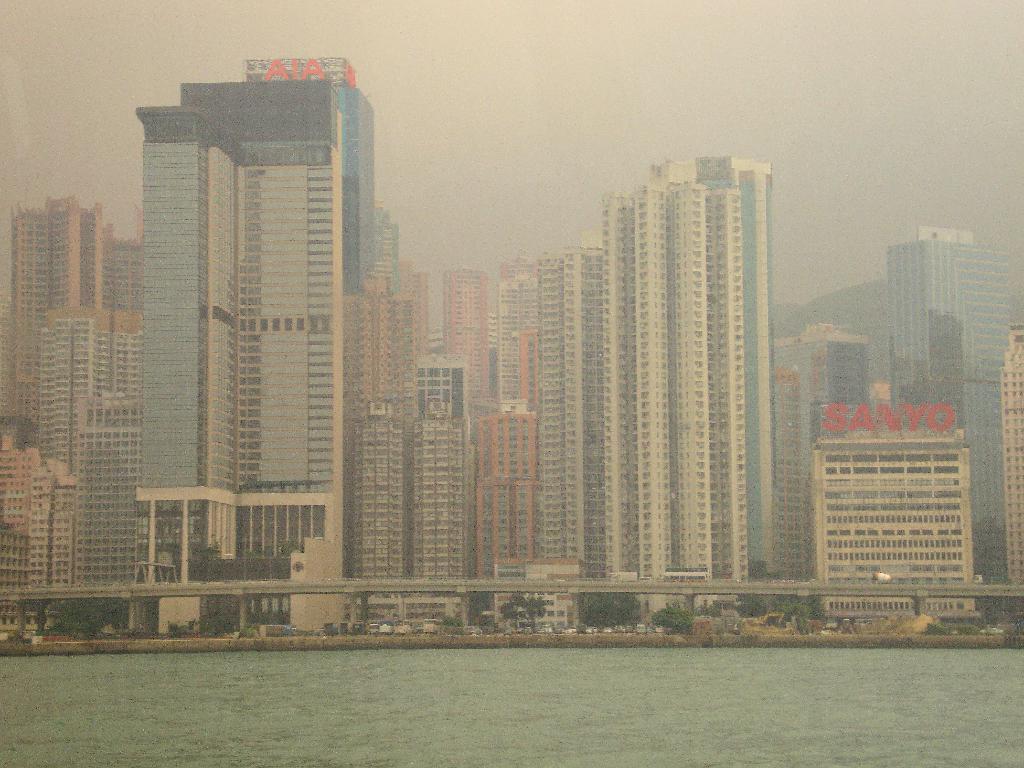Describe this image in one or two sentences. In this image I can see water, background I can see few buildings and sky in white color. 